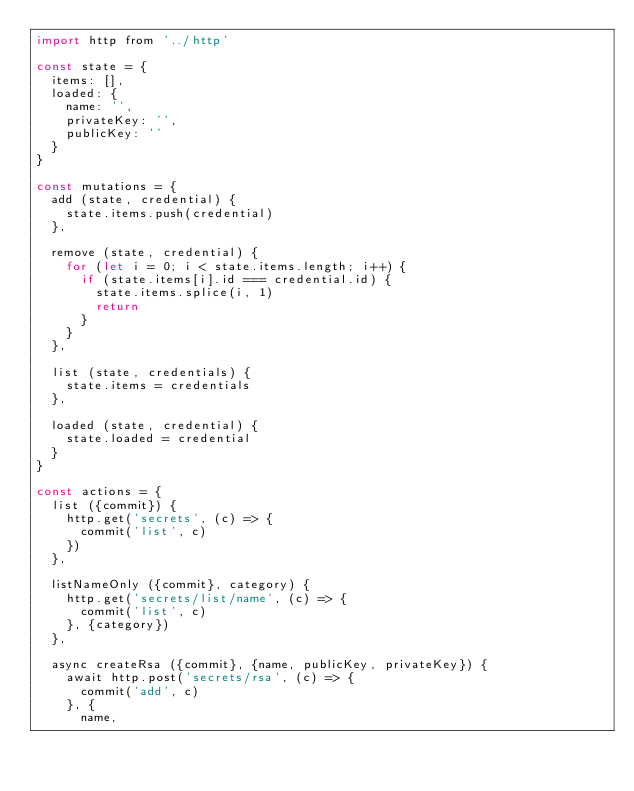Convert code to text. <code><loc_0><loc_0><loc_500><loc_500><_JavaScript_>import http from '../http'

const state = {
  items: [],
  loaded: {
    name: '',
    privateKey: '',
    publicKey: ''
  }
}

const mutations = {
  add (state, credential) {
    state.items.push(credential)
  },

  remove (state, credential) {
    for (let i = 0; i < state.items.length; i++) {
      if (state.items[i].id === credential.id) {
        state.items.splice(i, 1)
        return
      }
    }
  },

  list (state, credentials) {
    state.items = credentials
  },

  loaded (state, credential) {
    state.loaded = credential
  }
}

const actions = {
  list ({commit}) {
    http.get('secrets', (c) => {
      commit('list', c)
    })
  },

  listNameOnly ({commit}, category) {
    http.get('secrets/list/name', (c) => {
      commit('list', c)
    }, {category})
  },

  async createRsa ({commit}, {name, publicKey, privateKey}) {
    await http.post('secrets/rsa', (c) => {
      commit('add', c)
    }, {
      name,</code> 